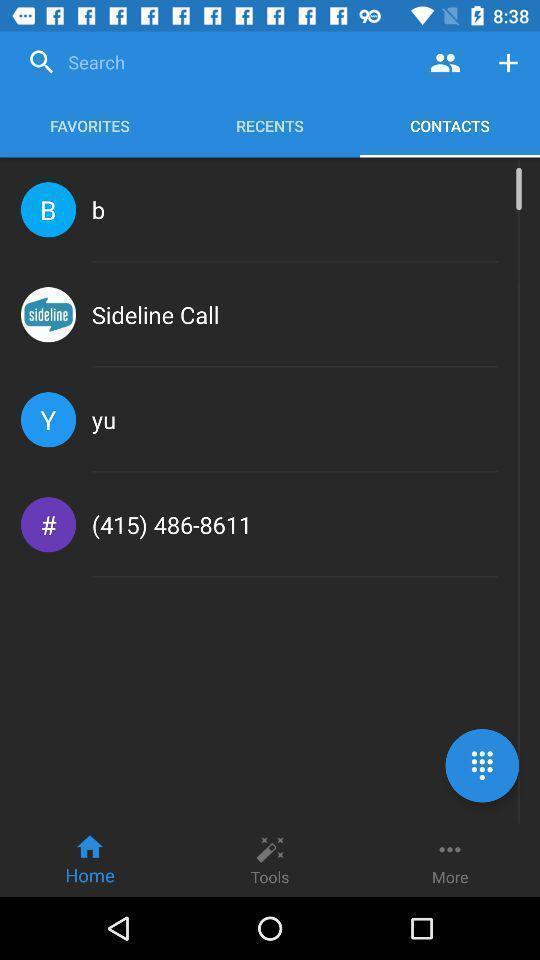Explain what's happening in this screen capture. Search bar to search contact. 